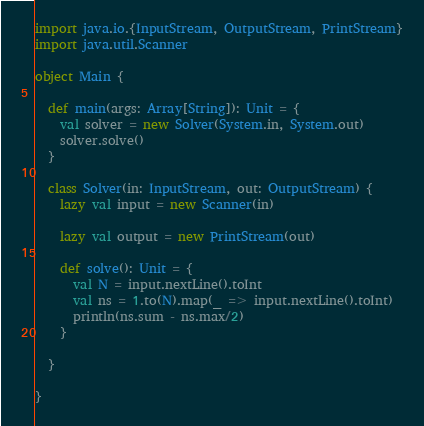<code> <loc_0><loc_0><loc_500><loc_500><_Scala_>import java.io.{InputStream, OutputStream, PrintStream}
import java.util.Scanner

object Main {

  def main(args: Array[String]): Unit = {
    val solver = new Solver(System.in, System.out)
    solver.solve()
  }

  class Solver(in: InputStream, out: OutputStream) {
    lazy val input = new Scanner(in)

    lazy val output = new PrintStream(out)

    def solve(): Unit = {
      val N = input.nextLine().toInt
      val ns = 1.to(N).map(_ => input.nextLine().toInt)
      println(ns.sum - ns.max/2)
    }

  }

}
</code> 